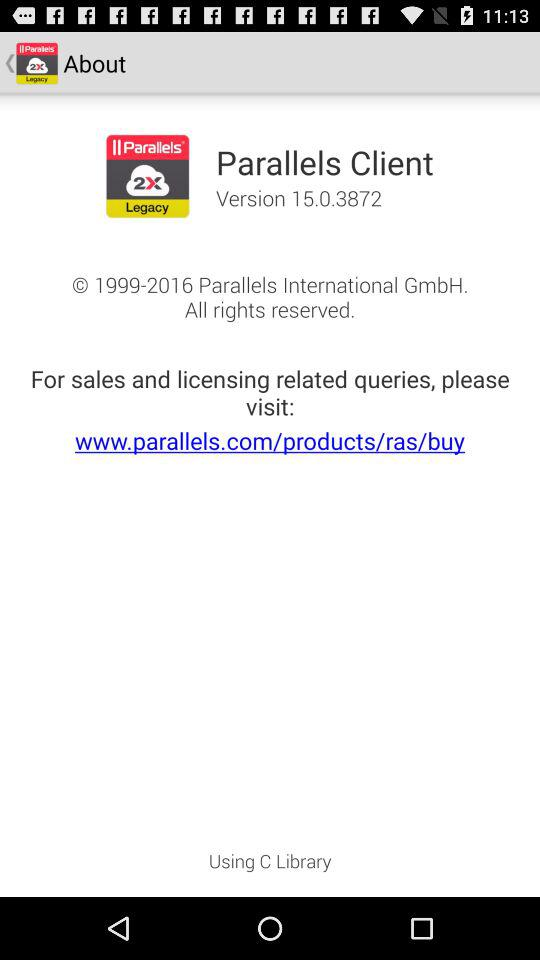What is the version? The version is 15.0.3872. 